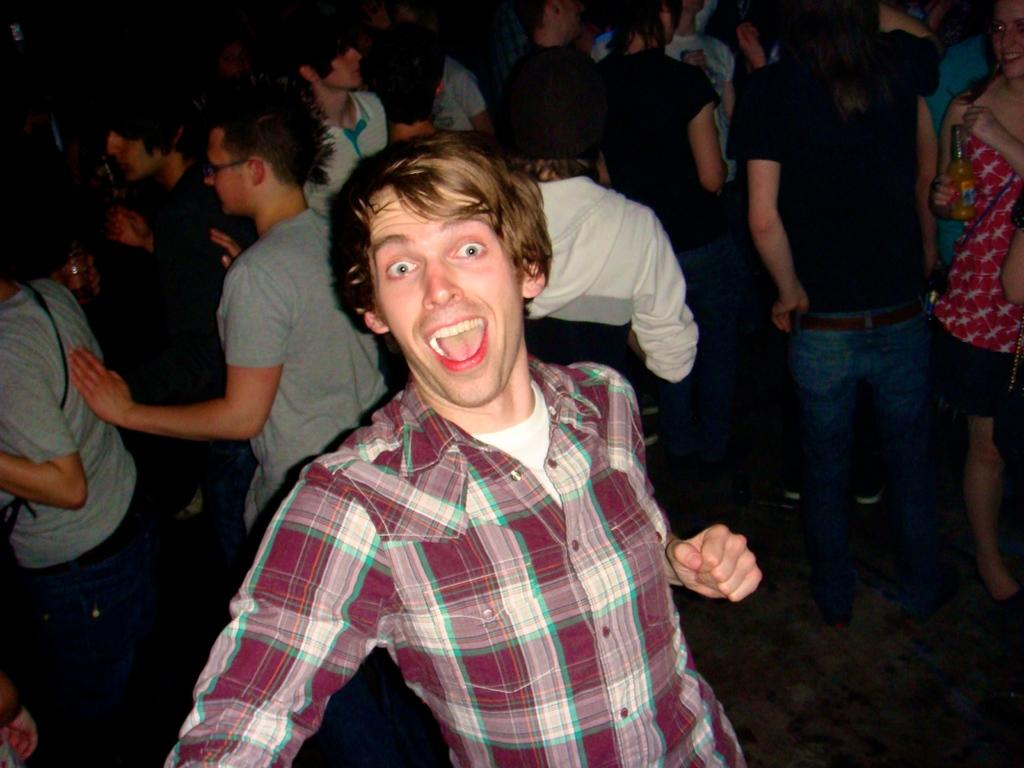How many people are in the image? The number of people in the image cannot be determined from the provided facts. What are the people doing in the image? The provided facts do not specify what the people are doing in the image. What is the surface on which the people are standing? The people are standing on the floor. What type of songs can be heard being sung by the people's tongues in the image? There is no mention of singing or tongues in the image, so it is not possible to answer this question. 